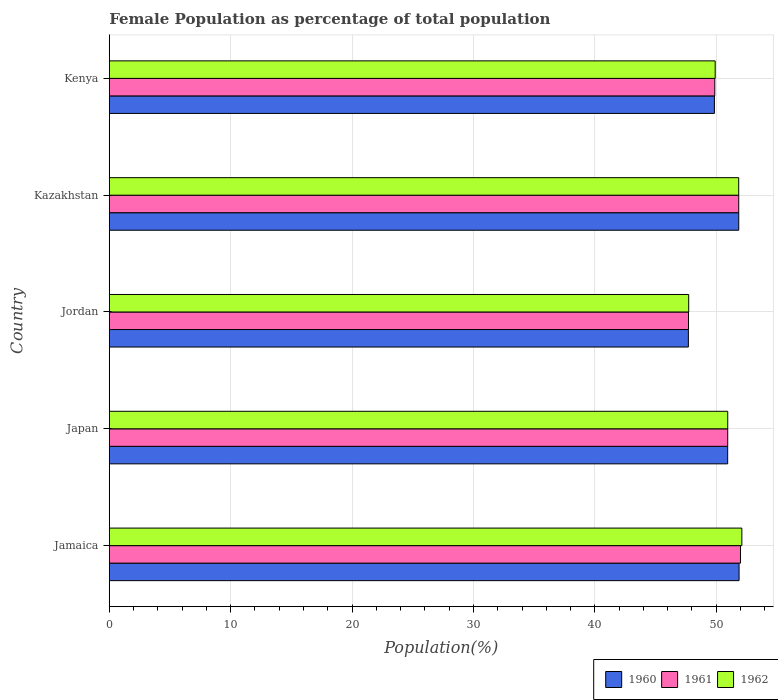How many different coloured bars are there?
Offer a terse response. 3. How many bars are there on the 1st tick from the top?
Your response must be concise. 3. What is the label of the 2nd group of bars from the top?
Offer a very short reply. Kazakhstan. In how many cases, is the number of bars for a given country not equal to the number of legend labels?
Your answer should be compact. 0. What is the female population in in 1960 in Jordan?
Ensure brevity in your answer.  47.7. Across all countries, what is the maximum female population in in 1961?
Keep it short and to the point. 52. Across all countries, what is the minimum female population in in 1960?
Offer a very short reply. 47.7. In which country was the female population in in 1961 maximum?
Provide a succinct answer. Jamaica. In which country was the female population in in 1962 minimum?
Ensure brevity in your answer.  Jordan. What is the total female population in in 1962 in the graph?
Your answer should be compact. 252.54. What is the difference between the female population in in 1960 in Jordan and that in Kenya?
Offer a terse response. -2.14. What is the difference between the female population in in 1961 in Kazakhstan and the female population in in 1960 in Kenya?
Keep it short and to the point. 2. What is the average female population in in 1961 per country?
Give a very brief answer. 50.48. What is the difference between the female population in in 1960 and female population in in 1962 in Kazakhstan?
Make the answer very short. 0. What is the ratio of the female population in in 1961 in Jamaica to that in Kenya?
Make the answer very short. 1.04. Is the difference between the female population in in 1960 in Kazakhstan and Kenya greater than the difference between the female population in in 1962 in Kazakhstan and Kenya?
Your response must be concise. Yes. What is the difference between the highest and the second highest female population in in 1962?
Your answer should be very brief. 0.26. What is the difference between the highest and the lowest female population in in 1961?
Keep it short and to the point. 4.29. Is the sum of the female population in in 1960 in Jamaica and Kenya greater than the maximum female population in in 1961 across all countries?
Provide a short and direct response. Yes. What does the 1st bar from the bottom in Kazakhstan represents?
Offer a terse response. 1960. Is it the case that in every country, the sum of the female population in in 1961 and female population in in 1960 is greater than the female population in in 1962?
Provide a succinct answer. Yes. Are all the bars in the graph horizontal?
Keep it short and to the point. Yes. Where does the legend appear in the graph?
Offer a very short reply. Bottom right. How many legend labels are there?
Your response must be concise. 3. What is the title of the graph?
Provide a short and direct response. Female Population as percentage of total population. What is the label or title of the X-axis?
Offer a very short reply. Population(%). What is the label or title of the Y-axis?
Give a very brief answer. Country. What is the Population(%) in 1960 in Jamaica?
Give a very brief answer. 51.88. What is the Population(%) of 1961 in Jamaica?
Ensure brevity in your answer.  52. What is the Population(%) of 1962 in Jamaica?
Keep it short and to the point. 52.11. What is the Population(%) in 1960 in Japan?
Keep it short and to the point. 50.94. What is the Population(%) in 1961 in Japan?
Offer a very short reply. 50.94. What is the Population(%) of 1962 in Japan?
Your answer should be very brief. 50.95. What is the Population(%) of 1960 in Jordan?
Your answer should be compact. 47.7. What is the Population(%) in 1961 in Jordan?
Keep it short and to the point. 47.71. What is the Population(%) in 1962 in Jordan?
Provide a short and direct response. 47.73. What is the Population(%) in 1960 in Kazakhstan?
Give a very brief answer. 51.85. What is the Population(%) of 1961 in Kazakhstan?
Offer a very short reply. 51.85. What is the Population(%) in 1962 in Kazakhstan?
Offer a very short reply. 51.85. What is the Population(%) in 1960 in Kenya?
Make the answer very short. 49.85. What is the Population(%) of 1961 in Kenya?
Provide a short and direct response. 49.88. What is the Population(%) of 1962 in Kenya?
Provide a succinct answer. 49.91. Across all countries, what is the maximum Population(%) of 1960?
Offer a terse response. 51.88. Across all countries, what is the maximum Population(%) of 1961?
Offer a very short reply. 52. Across all countries, what is the maximum Population(%) of 1962?
Ensure brevity in your answer.  52.11. Across all countries, what is the minimum Population(%) in 1960?
Give a very brief answer. 47.7. Across all countries, what is the minimum Population(%) in 1961?
Give a very brief answer. 47.71. Across all countries, what is the minimum Population(%) of 1962?
Provide a short and direct response. 47.73. What is the total Population(%) in 1960 in the graph?
Offer a very short reply. 252.22. What is the total Population(%) of 1961 in the graph?
Provide a short and direct response. 252.38. What is the total Population(%) of 1962 in the graph?
Your answer should be very brief. 252.54. What is the difference between the Population(%) in 1960 in Jamaica and that in Japan?
Your response must be concise. 0.94. What is the difference between the Population(%) of 1961 in Jamaica and that in Japan?
Keep it short and to the point. 1.05. What is the difference between the Population(%) in 1962 in Jamaica and that in Japan?
Your response must be concise. 1.16. What is the difference between the Population(%) in 1960 in Jamaica and that in Jordan?
Offer a terse response. 4.18. What is the difference between the Population(%) in 1961 in Jamaica and that in Jordan?
Make the answer very short. 4.29. What is the difference between the Population(%) in 1962 in Jamaica and that in Jordan?
Offer a terse response. 4.38. What is the difference between the Population(%) in 1960 in Jamaica and that in Kazakhstan?
Keep it short and to the point. 0.03. What is the difference between the Population(%) in 1961 in Jamaica and that in Kazakhstan?
Offer a terse response. 0.15. What is the difference between the Population(%) in 1962 in Jamaica and that in Kazakhstan?
Offer a terse response. 0.26. What is the difference between the Population(%) in 1960 in Jamaica and that in Kenya?
Provide a succinct answer. 2.03. What is the difference between the Population(%) of 1961 in Jamaica and that in Kenya?
Make the answer very short. 2.12. What is the difference between the Population(%) of 1962 in Jamaica and that in Kenya?
Offer a terse response. 2.2. What is the difference between the Population(%) in 1960 in Japan and that in Jordan?
Provide a short and direct response. 3.24. What is the difference between the Population(%) of 1961 in Japan and that in Jordan?
Your answer should be very brief. 3.23. What is the difference between the Population(%) of 1962 in Japan and that in Jordan?
Your answer should be very brief. 3.21. What is the difference between the Population(%) of 1960 in Japan and that in Kazakhstan?
Provide a short and direct response. -0.91. What is the difference between the Population(%) of 1961 in Japan and that in Kazakhstan?
Give a very brief answer. -0.91. What is the difference between the Population(%) of 1962 in Japan and that in Kazakhstan?
Provide a short and direct response. -0.9. What is the difference between the Population(%) of 1960 in Japan and that in Kenya?
Keep it short and to the point. 1.09. What is the difference between the Population(%) of 1961 in Japan and that in Kenya?
Provide a short and direct response. 1.07. What is the difference between the Population(%) of 1962 in Japan and that in Kenya?
Your answer should be very brief. 1.03. What is the difference between the Population(%) in 1960 in Jordan and that in Kazakhstan?
Offer a very short reply. -4.15. What is the difference between the Population(%) of 1961 in Jordan and that in Kazakhstan?
Offer a terse response. -4.14. What is the difference between the Population(%) in 1962 in Jordan and that in Kazakhstan?
Your response must be concise. -4.12. What is the difference between the Population(%) of 1960 in Jordan and that in Kenya?
Give a very brief answer. -2.14. What is the difference between the Population(%) in 1961 in Jordan and that in Kenya?
Offer a terse response. -2.17. What is the difference between the Population(%) in 1962 in Jordan and that in Kenya?
Provide a short and direct response. -2.18. What is the difference between the Population(%) in 1960 in Kazakhstan and that in Kenya?
Provide a succinct answer. 2. What is the difference between the Population(%) of 1961 in Kazakhstan and that in Kenya?
Make the answer very short. 1.97. What is the difference between the Population(%) in 1962 in Kazakhstan and that in Kenya?
Your answer should be very brief. 1.94. What is the difference between the Population(%) of 1960 in Jamaica and the Population(%) of 1961 in Japan?
Give a very brief answer. 0.94. What is the difference between the Population(%) in 1960 in Jamaica and the Population(%) in 1962 in Japan?
Provide a succinct answer. 0.93. What is the difference between the Population(%) of 1961 in Jamaica and the Population(%) of 1962 in Japan?
Provide a short and direct response. 1.05. What is the difference between the Population(%) of 1960 in Jamaica and the Population(%) of 1961 in Jordan?
Offer a terse response. 4.17. What is the difference between the Population(%) in 1960 in Jamaica and the Population(%) in 1962 in Jordan?
Keep it short and to the point. 4.15. What is the difference between the Population(%) of 1961 in Jamaica and the Population(%) of 1962 in Jordan?
Your answer should be compact. 4.27. What is the difference between the Population(%) of 1960 in Jamaica and the Population(%) of 1961 in Kazakhstan?
Your answer should be very brief. 0.03. What is the difference between the Population(%) in 1960 in Jamaica and the Population(%) in 1962 in Kazakhstan?
Your response must be concise. 0.03. What is the difference between the Population(%) in 1961 in Jamaica and the Population(%) in 1962 in Kazakhstan?
Your answer should be very brief. 0.15. What is the difference between the Population(%) in 1960 in Jamaica and the Population(%) in 1961 in Kenya?
Ensure brevity in your answer.  2. What is the difference between the Population(%) in 1960 in Jamaica and the Population(%) in 1962 in Kenya?
Offer a terse response. 1.97. What is the difference between the Population(%) in 1961 in Jamaica and the Population(%) in 1962 in Kenya?
Make the answer very short. 2.09. What is the difference between the Population(%) in 1960 in Japan and the Population(%) in 1961 in Jordan?
Make the answer very short. 3.23. What is the difference between the Population(%) in 1960 in Japan and the Population(%) in 1962 in Jordan?
Your answer should be compact. 3.21. What is the difference between the Population(%) of 1961 in Japan and the Population(%) of 1962 in Jordan?
Keep it short and to the point. 3.21. What is the difference between the Population(%) of 1960 in Japan and the Population(%) of 1961 in Kazakhstan?
Your answer should be compact. -0.91. What is the difference between the Population(%) of 1960 in Japan and the Population(%) of 1962 in Kazakhstan?
Make the answer very short. -0.91. What is the difference between the Population(%) in 1961 in Japan and the Population(%) in 1962 in Kazakhstan?
Keep it short and to the point. -0.9. What is the difference between the Population(%) in 1960 in Japan and the Population(%) in 1961 in Kenya?
Provide a short and direct response. 1.06. What is the difference between the Population(%) in 1960 in Japan and the Population(%) in 1962 in Kenya?
Your response must be concise. 1.03. What is the difference between the Population(%) of 1961 in Japan and the Population(%) of 1962 in Kenya?
Provide a succinct answer. 1.03. What is the difference between the Population(%) in 1960 in Jordan and the Population(%) in 1961 in Kazakhstan?
Your response must be concise. -4.15. What is the difference between the Population(%) of 1960 in Jordan and the Population(%) of 1962 in Kazakhstan?
Make the answer very short. -4.15. What is the difference between the Population(%) in 1961 in Jordan and the Population(%) in 1962 in Kazakhstan?
Give a very brief answer. -4.14. What is the difference between the Population(%) in 1960 in Jordan and the Population(%) in 1961 in Kenya?
Offer a terse response. -2.18. What is the difference between the Population(%) in 1960 in Jordan and the Population(%) in 1962 in Kenya?
Your response must be concise. -2.21. What is the difference between the Population(%) in 1961 in Jordan and the Population(%) in 1962 in Kenya?
Offer a terse response. -2.2. What is the difference between the Population(%) in 1960 in Kazakhstan and the Population(%) in 1961 in Kenya?
Your answer should be very brief. 1.97. What is the difference between the Population(%) in 1960 in Kazakhstan and the Population(%) in 1962 in Kenya?
Provide a short and direct response. 1.94. What is the difference between the Population(%) in 1961 in Kazakhstan and the Population(%) in 1962 in Kenya?
Your answer should be compact. 1.94. What is the average Population(%) of 1960 per country?
Make the answer very short. 50.44. What is the average Population(%) of 1961 per country?
Ensure brevity in your answer.  50.48. What is the average Population(%) of 1962 per country?
Provide a succinct answer. 50.51. What is the difference between the Population(%) of 1960 and Population(%) of 1961 in Jamaica?
Make the answer very short. -0.12. What is the difference between the Population(%) in 1960 and Population(%) in 1962 in Jamaica?
Give a very brief answer. -0.23. What is the difference between the Population(%) in 1961 and Population(%) in 1962 in Jamaica?
Keep it short and to the point. -0.11. What is the difference between the Population(%) of 1960 and Population(%) of 1961 in Japan?
Keep it short and to the point. -0. What is the difference between the Population(%) of 1960 and Population(%) of 1962 in Japan?
Provide a short and direct response. -0. What is the difference between the Population(%) of 1961 and Population(%) of 1962 in Japan?
Provide a succinct answer. -0. What is the difference between the Population(%) of 1960 and Population(%) of 1961 in Jordan?
Provide a short and direct response. -0.01. What is the difference between the Population(%) in 1960 and Population(%) in 1962 in Jordan?
Make the answer very short. -0.03. What is the difference between the Population(%) of 1961 and Population(%) of 1962 in Jordan?
Keep it short and to the point. -0.02. What is the difference between the Population(%) in 1960 and Population(%) in 1962 in Kazakhstan?
Keep it short and to the point. 0. What is the difference between the Population(%) in 1961 and Population(%) in 1962 in Kazakhstan?
Ensure brevity in your answer.  0. What is the difference between the Population(%) in 1960 and Population(%) in 1961 in Kenya?
Make the answer very short. -0.03. What is the difference between the Population(%) of 1960 and Population(%) of 1962 in Kenya?
Offer a very short reply. -0.06. What is the difference between the Population(%) of 1961 and Population(%) of 1962 in Kenya?
Provide a short and direct response. -0.03. What is the ratio of the Population(%) of 1960 in Jamaica to that in Japan?
Give a very brief answer. 1.02. What is the ratio of the Population(%) of 1961 in Jamaica to that in Japan?
Offer a terse response. 1.02. What is the ratio of the Population(%) in 1962 in Jamaica to that in Japan?
Your answer should be compact. 1.02. What is the ratio of the Population(%) of 1960 in Jamaica to that in Jordan?
Make the answer very short. 1.09. What is the ratio of the Population(%) of 1961 in Jamaica to that in Jordan?
Make the answer very short. 1.09. What is the ratio of the Population(%) in 1962 in Jamaica to that in Jordan?
Offer a terse response. 1.09. What is the ratio of the Population(%) in 1961 in Jamaica to that in Kazakhstan?
Keep it short and to the point. 1. What is the ratio of the Population(%) of 1960 in Jamaica to that in Kenya?
Make the answer very short. 1.04. What is the ratio of the Population(%) of 1961 in Jamaica to that in Kenya?
Offer a terse response. 1.04. What is the ratio of the Population(%) of 1962 in Jamaica to that in Kenya?
Give a very brief answer. 1.04. What is the ratio of the Population(%) in 1960 in Japan to that in Jordan?
Give a very brief answer. 1.07. What is the ratio of the Population(%) of 1961 in Japan to that in Jordan?
Your answer should be compact. 1.07. What is the ratio of the Population(%) of 1962 in Japan to that in Jordan?
Provide a short and direct response. 1.07. What is the ratio of the Population(%) in 1960 in Japan to that in Kazakhstan?
Your response must be concise. 0.98. What is the ratio of the Population(%) of 1961 in Japan to that in Kazakhstan?
Your answer should be very brief. 0.98. What is the ratio of the Population(%) of 1962 in Japan to that in Kazakhstan?
Your answer should be compact. 0.98. What is the ratio of the Population(%) in 1960 in Japan to that in Kenya?
Provide a succinct answer. 1.02. What is the ratio of the Population(%) in 1961 in Japan to that in Kenya?
Provide a succinct answer. 1.02. What is the ratio of the Population(%) in 1962 in Japan to that in Kenya?
Make the answer very short. 1.02. What is the ratio of the Population(%) in 1961 in Jordan to that in Kazakhstan?
Offer a very short reply. 0.92. What is the ratio of the Population(%) of 1962 in Jordan to that in Kazakhstan?
Make the answer very short. 0.92. What is the ratio of the Population(%) of 1961 in Jordan to that in Kenya?
Offer a very short reply. 0.96. What is the ratio of the Population(%) of 1962 in Jordan to that in Kenya?
Ensure brevity in your answer.  0.96. What is the ratio of the Population(%) of 1960 in Kazakhstan to that in Kenya?
Your answer should be compact. 1.04. What is the ratio of the Population(%) of 1961 in Kazakhstan to that in Kenya?
Make the answer very short. 1.04. What is the ratio of the Population(%) in 1962 in Kazakhstan to that in Kenya?
Offer a very short reply. 1.04. What is the difference between the highest and the second highest Population(%) of 1960?
Offer a terse response. 0.03. What is the difference between the highest and the second highest Population(%) of 1961?
Your answer should be very brief. 0.15. What is the difference between the highest and the second highest Population(%) of 1962?
Your answer should be very brief. 0.26. What is the difference between the highest and the lowest Population(%) of 1960?
Your response must be concise. 4.18. What is the difference between the highest and the lowest Population(%) of 1961?
Give a very brief answer. 4.29. What is the difference between the highest and the lowest Population(%) in 1962?
Provide a short and direct response. 4.38. 